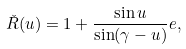Convert formula to latex. <formula><loc_0><loc_0><loc_500><loc_500>\check { R } ( u ) = 1 + \frac { \sin u } { \sin ( \gamma - u ) } e ,</formula> 